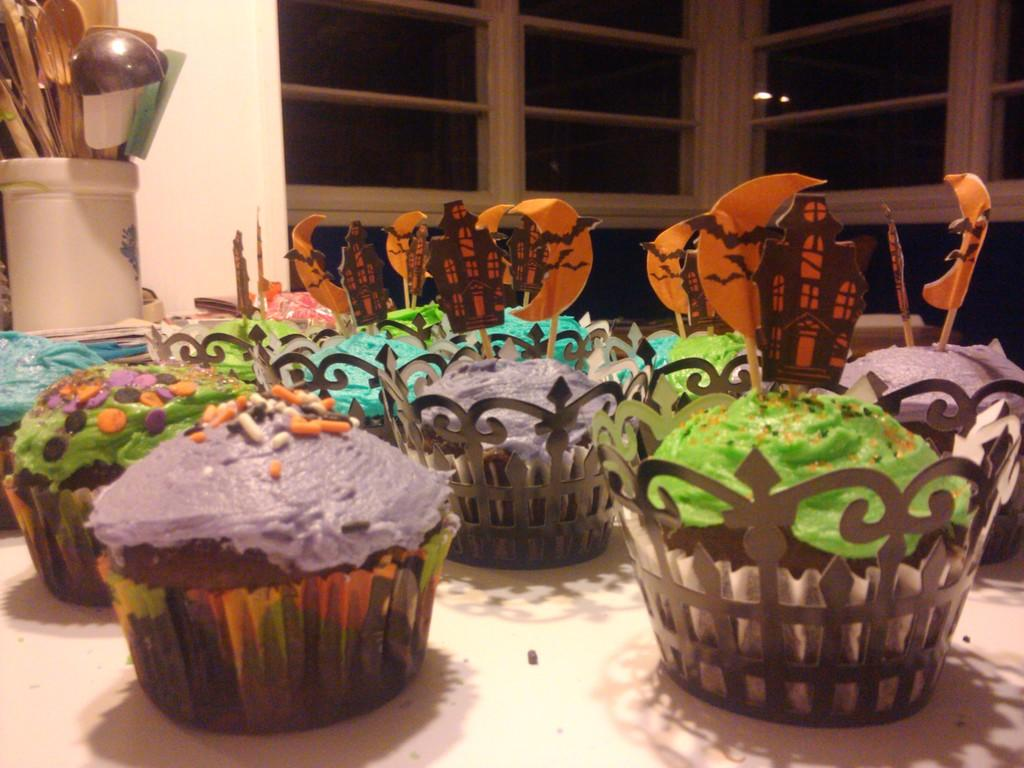What type of food can be seen in the image? There are cupcakes in the image. Where are the cupcakes located in the image? The cupcakes are in the front of the image. What other object is visible in the image? There is a glass in the image. Where is the glass located in the image? The glass is on the top left side of the image. What can be seen inside the glass? There are various items visible inside the glass. What type of news can be heard coming from the cupcakes in the image? There is no indication in the image that the cupcakes are producing any news or sounds. 